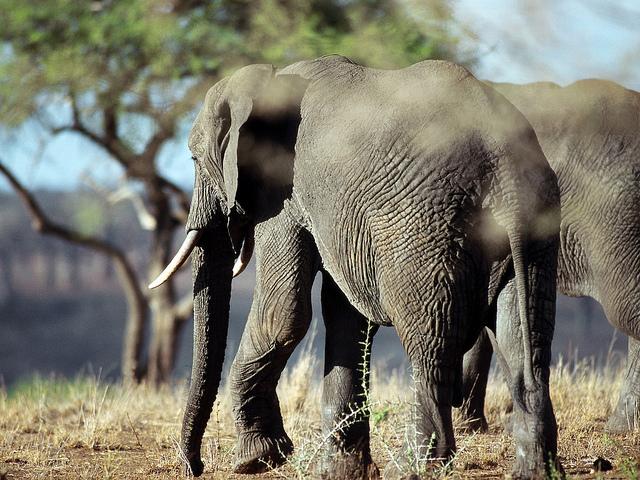What color are the leaves on the tree?
Write a very short answer. Green. What direction is the elephant in the background facing?
Short answer required. Left. How many elephants are there?
Write a very short answer. 2. Is there mud on his trunk?
Quick response, please. No. Does the elephant have a tusk?
Keep it brief. Yes. 